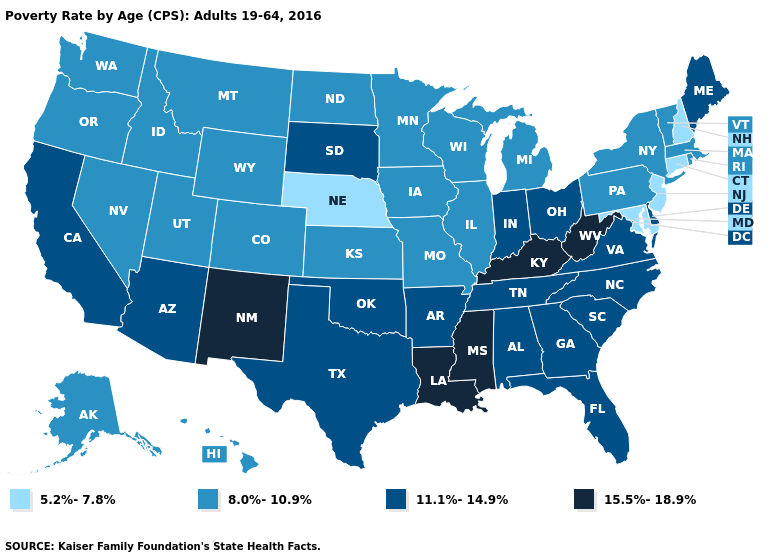Among the states that border Nevada , which have the lowest value?
Give a very brief answer. Idaho, Oregon, Utah. Name the states that have a value in the range 15.5%-18.9%?
Short answer required. Kentucky, Louisiana, Mississippi, New Mexico, West Virginia. Name the states that have a value in the range 8.0%-10.9%?
Be succinct. Alaska, Colorado, Hawaii, Idaho, Illinois, Iowa, Kansas, Massachusetts, Michigan, Minnesota, Missouri, Montana, Nevada, New York, North Dakota, Oregon, Pennsylvania, Rhode Island, Utah, Vermont, Washington, Wisconsin, Wyoming. Does Minnesota have a higher value than Nebraska?
Give a very brief answer. Yes. What is the highest value in the USA?
Give a very brief answer. 15.5%-18.9%. Which states have the lowest value in the MidWest?
Quick response, please. Nebraska. What is the value of Washington?
Quick response, please. 8.0%-10.9%. What is the lowest value in the USA?
Be succinct. 5.2%-7.8%. Is the legend a continuous bar?
Keep it brief. No. Does Idaho have the same value as Connecticut?
Give a very brief answer. No. What is the value of Pennsylvania?
Write a very short answer. 8.0%-10.9%. Does the first symbol in the legend represent the smallest category?
Short answer required. Yes. Name the states that have a value in the range 5.2%-7.8%?
Quick response, please. Connecticut, Maryland, Nebraska, New Hampshire, New Jersey. What is the value of Alabama?
Be succinct. 11.1%-14.9%. 